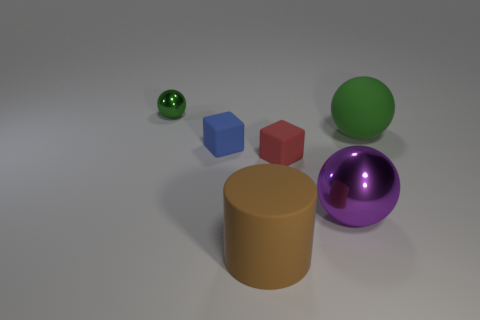Add 4 purple spheres. How many objects exist? 10 Subtract all yellow blocks. Subtract all green cylinders. How many blocks are left? 2 Subtract all cylinders. How many objects are left? 5 Subtract all large brown cylinders. Subtract all large metallic balls. How many objects are left? 4 Add 2 purple shiny objects. How many purple shiny objects are left? 3 Add 4 large balls. How many large balls exist? 6 Subtract 1 green balls. How many objects are left? 5 